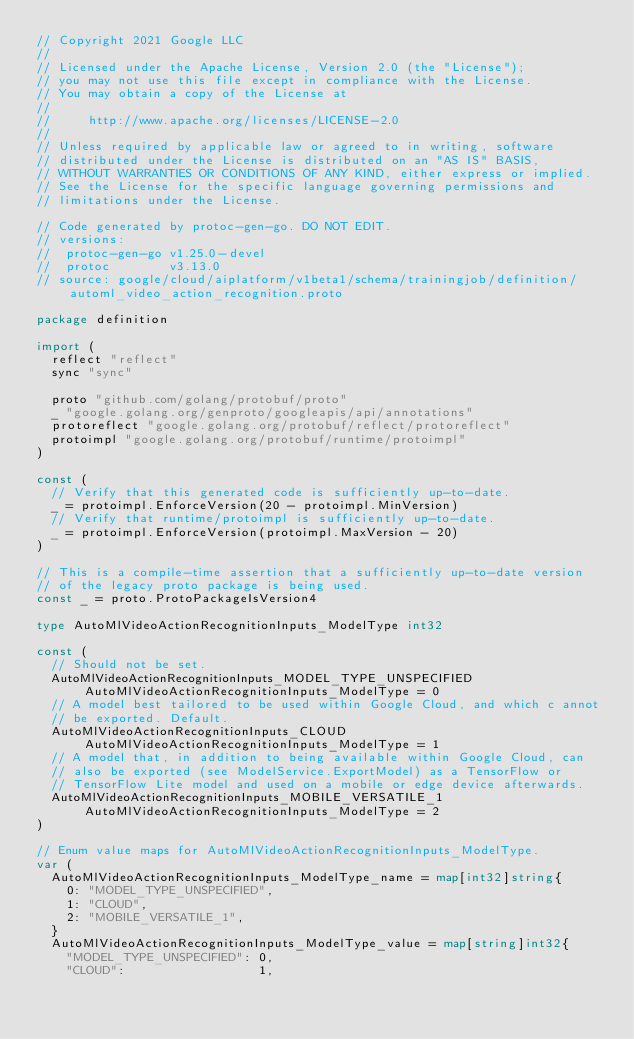<code> <loc_0><loc_0><loc_500><loc_500><_Go_>// Copyright 2021 Google LLC
//
// Licensed under the Apache License, Version 2.0 (the "License");
// you may not use this file except in compliance with the License.
// You may obtain a copy of the License at
//
//     http://www.apache.org/licenses/LICENSE-2.0
//
// Unless required by applicable law or agreed to in writing, software
// distributed under the License is distributed on an "AS IS" BASIS,
// WITHOUT WARRANTIES OR CONDITIONS OF ANY KIND, either express or implied.
// See the License for the specific language governing permissions and
// limitations under the License.

// Code generated by protoc-gen-go. DO NOT EDIT.
// versions:
// 	protoc-gen-go v1.25.0-devel
// 	protoc        v3.13.0
// source: google/cloud/aiplatform/v1beta1/schema/trainingjob/definition/automl_video_action_recognition.proto

package definition

import (
	reflect "reflect"
	sync "sync"

	proto "github.com/golang/protobuf/proto"
	_ "google.golang.org/genproto/googleapis/api/annotations"
	protoreflect "google.golang.org/protobuf/reflect/protoreflect"
	protoimpl "google.golang.org/protobuf/runtime/protoimpl"
)

const (
	// Verify that this generated code is sufficiently up-to-date.
	_ = protoimpl.EnforceVersion(20 - protoimpl.MinVersion)
	// Verify that runtime/protoimpl is sufficiently up-to-date.
	_ = protoimpl.EnforceVersion(protoimpl.MaxVersion - 20)
)

// This is a compile-time assertion that a sufficiently up-to-date version
// of the legacy proto package is being used.
const _ = proto.ProtoPackageIsVersion4

type AutoMlVideoActionRecognitionInputs_ModelType int32

const (
	// Should not be set.
	AutoMlVideoActionRecognitionInputs_MODEL_TYPE_UNSPECIFIED AutoMlVideoActionRecognitionInputs_ModelType = 0
	// A model best tailored to be used within Google Cloud, and which c annot
	// be exported. Default.
	AutoMlVideoActionRecognitionInputs_CLOUD AutoMlVideoActionRecognitionInputs_ModelType = 1
	// A model that, in addition to being available within Google Cloud, can
	// also be exported (see ModelService.ExportModel) as a TensorFlow or
	// TensorFlow Lite model and used on a mobile or edge device afterwards.
	AutoMlVideoActionRecognitionInputs_MOBILE_VERSATILE_1 AutoMlVideoActionRecognitionInputs_ModelType = 2
)

// Enum value maps for AutoMlVideoActionRecognitionInputs_ModelType.
var (
	AutoMlVideoActionRecognitionInputs_ModelType_name = map[int32]string{
		0: "MODEL_TYPE_UNSPECIFIED",
		1: "CLOUD",
		2: "MOBILE_VERSATILE_1",
	}
	AutoMlVideoActionRecognitionInputs_ModelType_value = map[string]int32{
		"MODEL_TYPE_UNSPECIFIED": 0,
		"CLOUD":                  1,</code> 